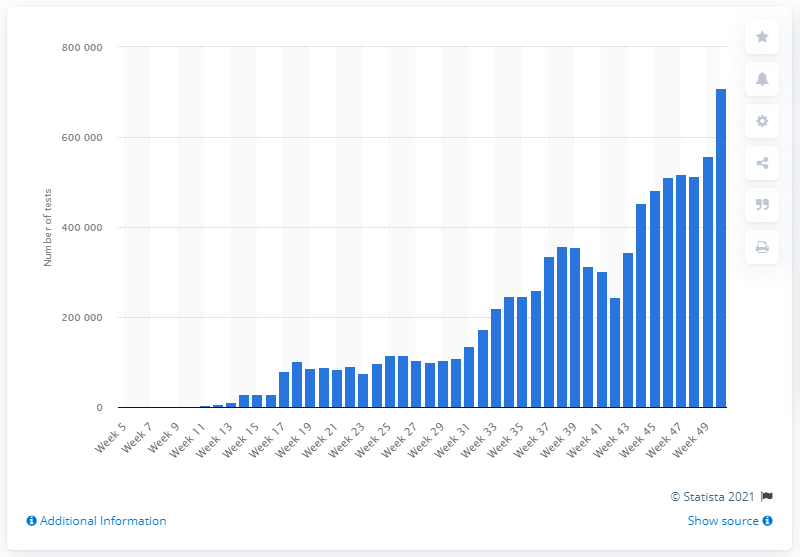Highlight a few significant elements in this photo. During the period of December 7th to December 13th, a total of 708088 tests were conducted. 